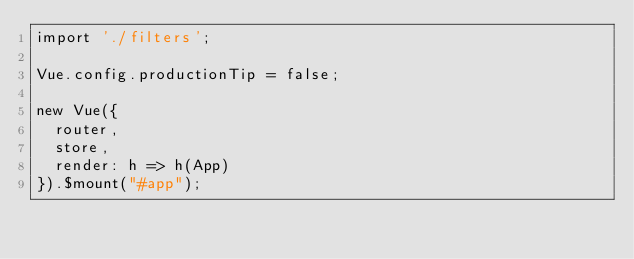Convert code to text. <code><loc_0><loc_0><loc_500><loc_500><_JavaScript_>import './filters';

Vue.config.productionTip = false;

new Vue({
  router,
  store,
  render: h => h(App)
}).$mount("#app");
</code> 